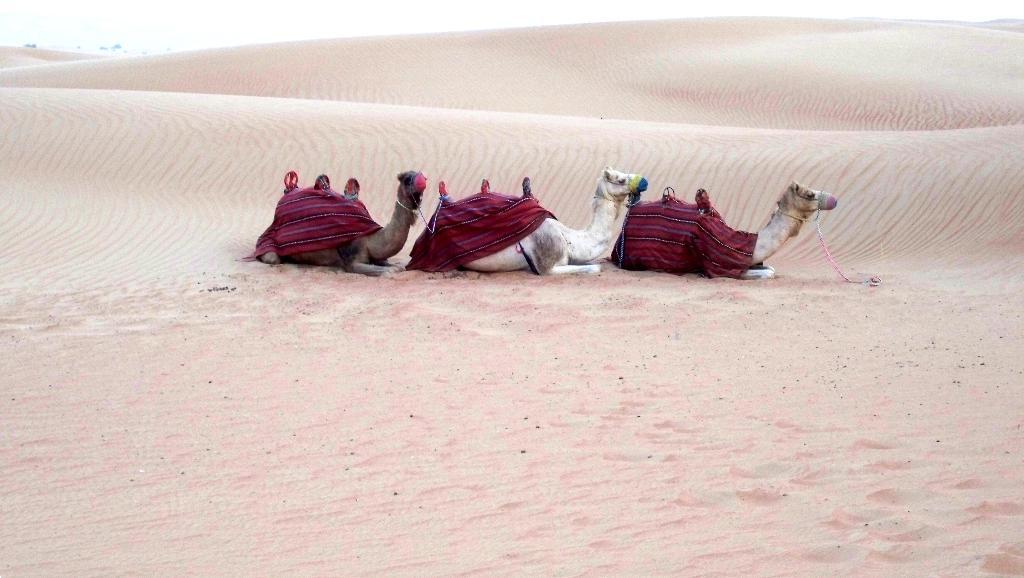How many camels are in the image? There are three camels in the image. Where are the camels located? The camels are in a desert. What type of terrain is visible in the image? Sand is visible in the image. What is on the back of each camel? There is a cloth and a seat on the back of each camel. What month is it in the image? The month cannot be determined from the image, as it does not contain any information about the time of year. 